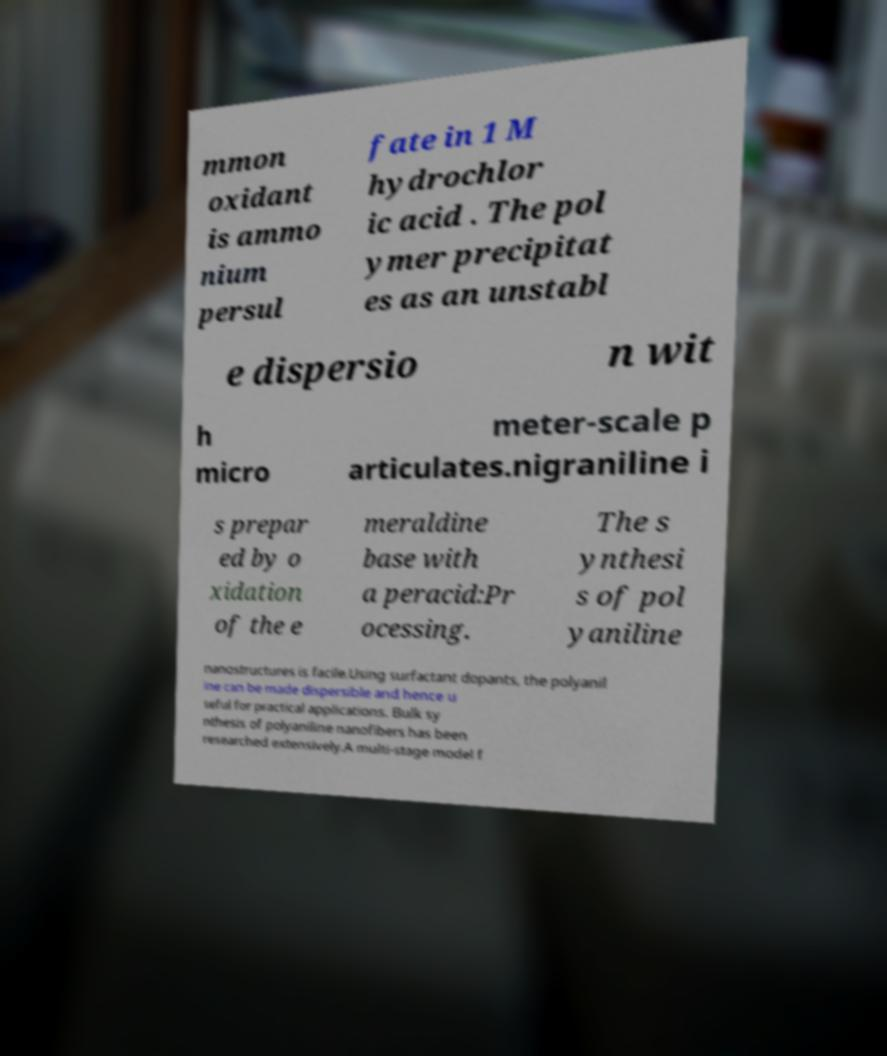Please identify and transcribe the text found in this image. mmon oxidant is ammo nium persul fate in 1 M hydrochlor ic acid . The pol ymer precipitat es as an unstabl e dispersio n wit h micro meter-scale p articulates.nigraniline i s prepar ed by o xidation of the e meraldine base with a peracid:Pr ocessing. The s ynthesi s of pol yaniline nanostructures is facile.Using surfactant dopants, the polyanil ine can be made dispersible and hence u seful for practical applications. Bulk sy nthesis of polyaniline nanofibers has been researched extensively.A multi-stage model f 